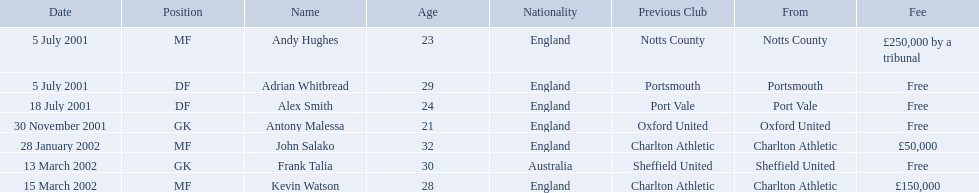What are all of the names? Andy Hughes, Adrian Whitbread, Alex Smith, Antony Malessa, John Salako, Frank Talia, Kevin Watson. What was the fee for each person? £250,000 by a tribunal, Free, Free, Free, £50,000, Free, £150,000. And who had the highest fee? Andy Hughes. What are the names of all the players? Andy Hughes, Adrian Whitbread, Alex Smith, Antony Malessa, John Salako, Frank Talia, Kevin Watson. What fee did andy hughes command? £250,000 by a tribunal. What fee did john salako command? £50,000. Which player had the highest fee, andy hughes or john salako? Andy Hughes. 